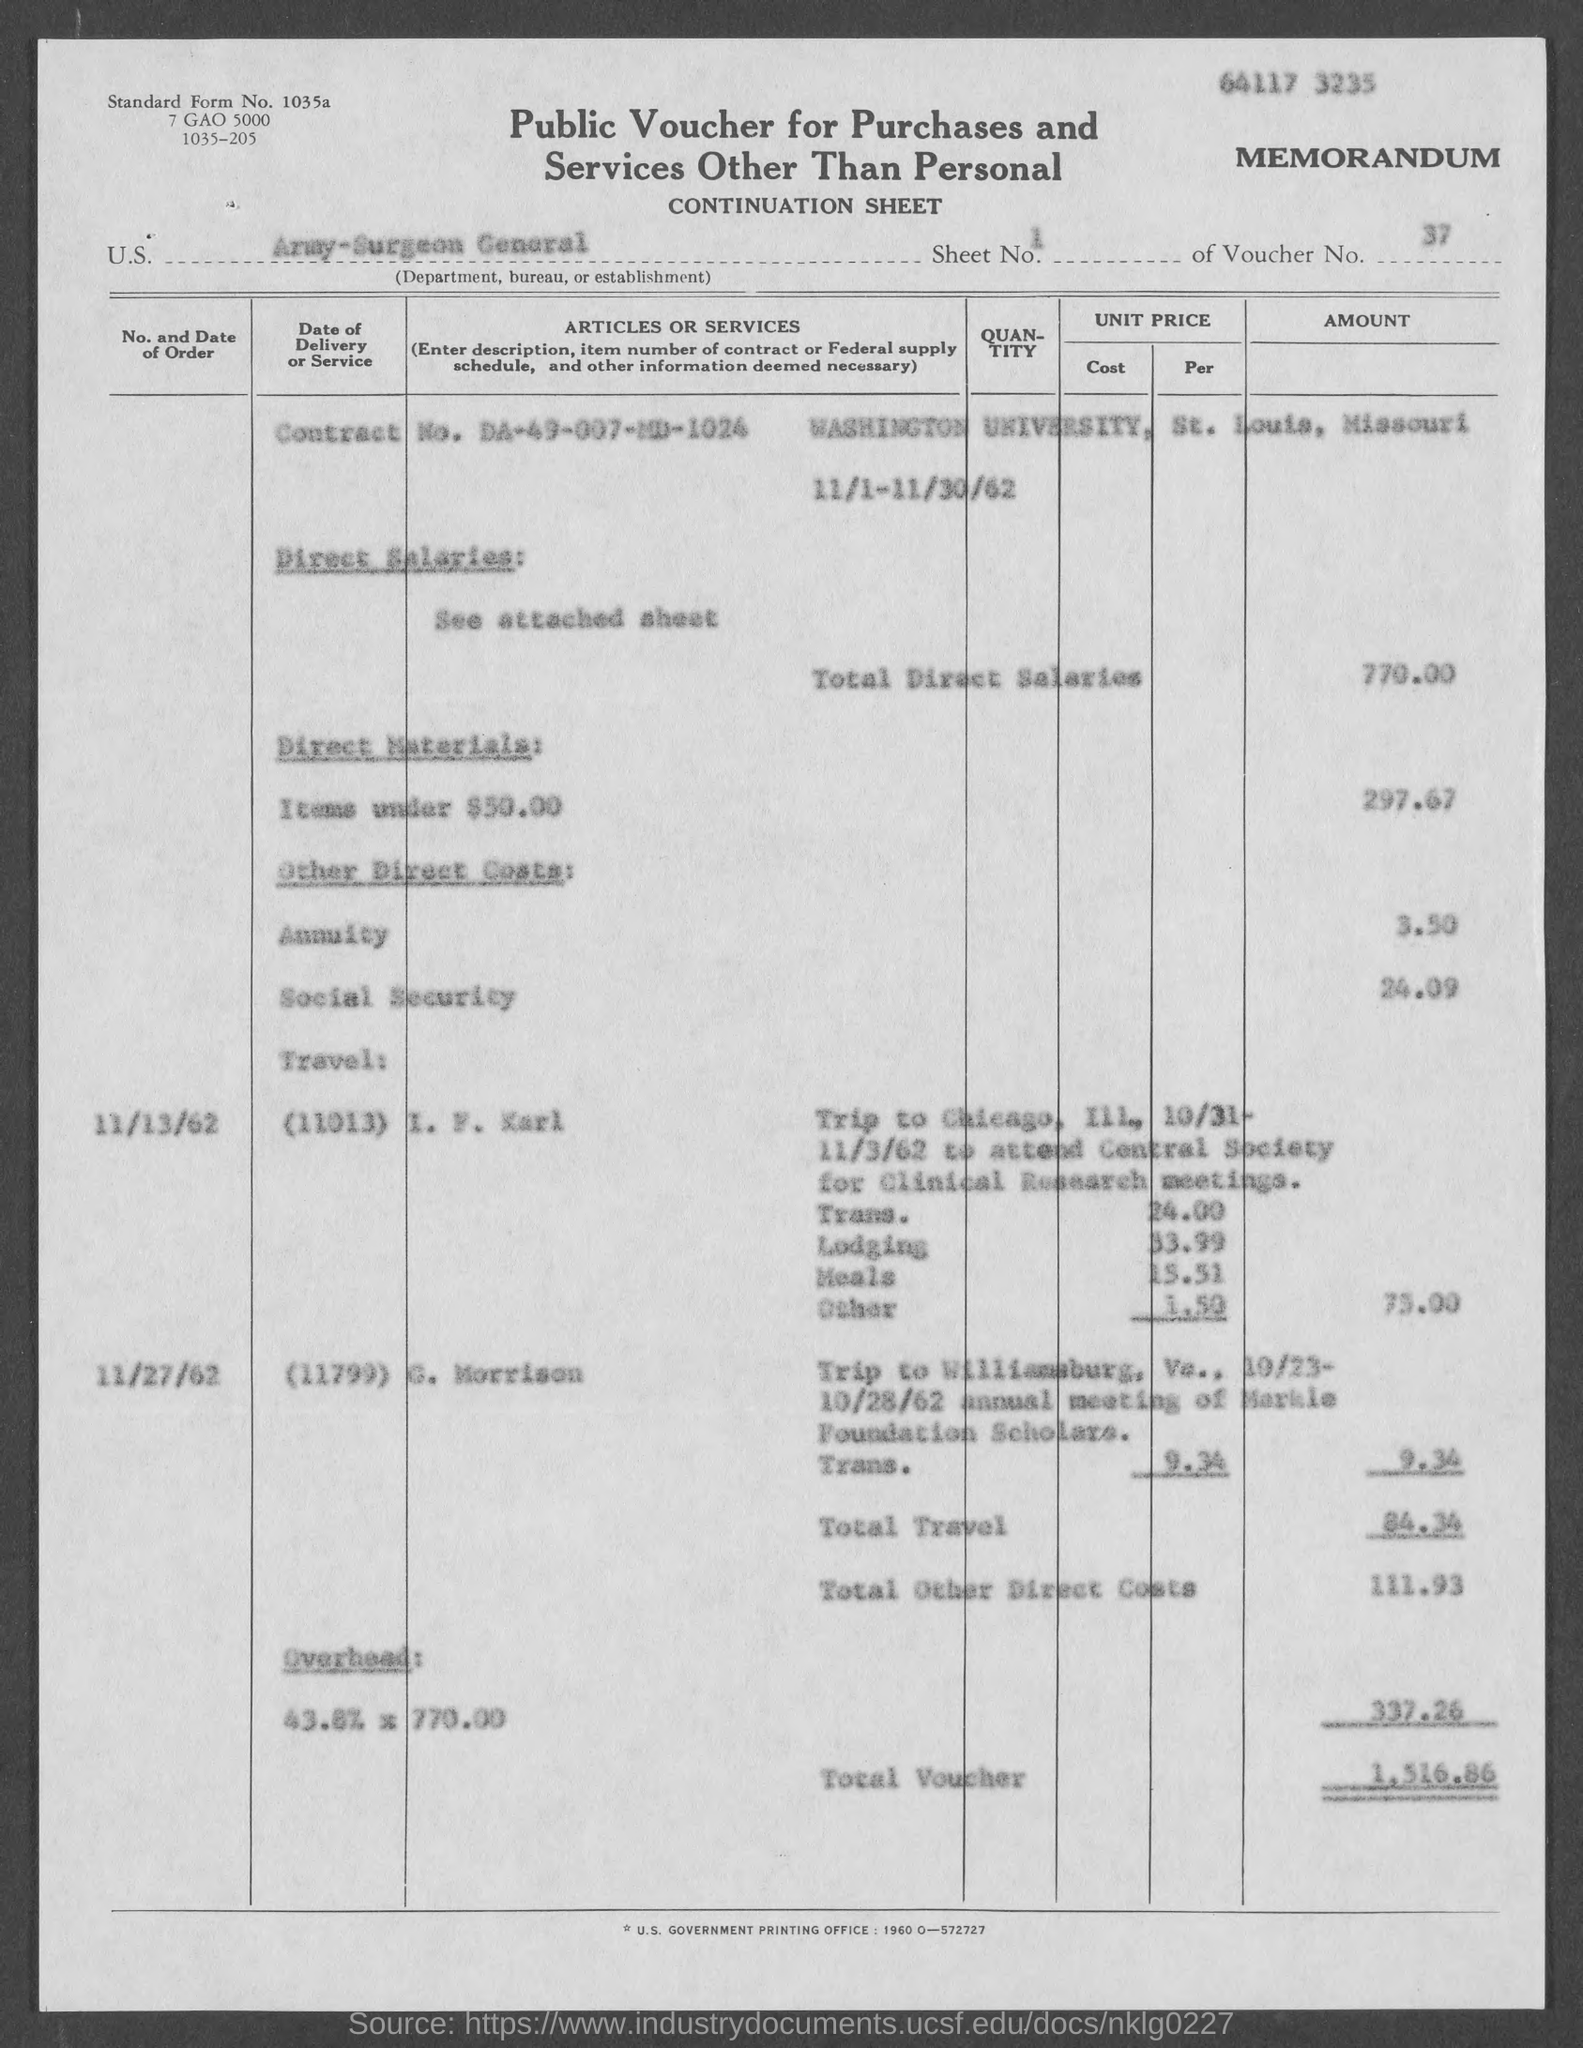What was the purpose of the travel to Chicago listed on this form? The form indicates the travel to Chicago on 11/3/62 was for 'E. M. Karl' to attend the 'General Society for Clinical Research' meetings. The costs cover transportation, lodging, meals, and other expenses. How much was spent on meals during that Chicago trip? According to the document, a total of $5.52 was spent on meals during the Chicago trip. 